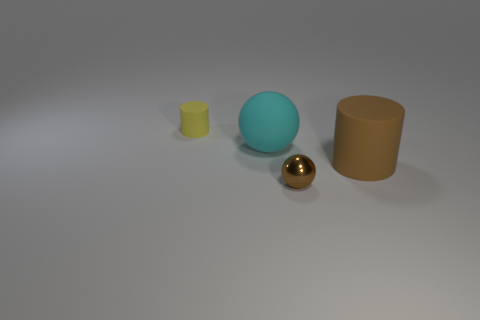If these objects were real, how might they be used in everyday life? If these were real objects, the balls could serve as decorative items or perhaps sports equipment, depending on their material and size. The cylinders might be containers, like canisters for storage, or elements of some larger machinery or structural elements, without additional context it's hard to ascertain their exact use. 